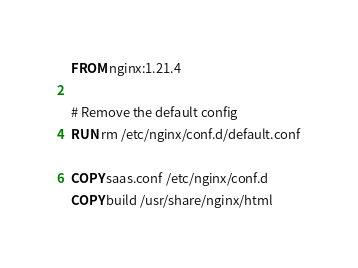<code> <loc_0><loc_0><loc_500><loc_500><_Dockerfile_>FROM nginx:1.21.4

# Remove the default config
RUN rm /etc/nginx/conf.d/default.conf

COPY saas.conf /etc/nginx/conf.d
COPY build /usr/share/nginx/html
</code> 